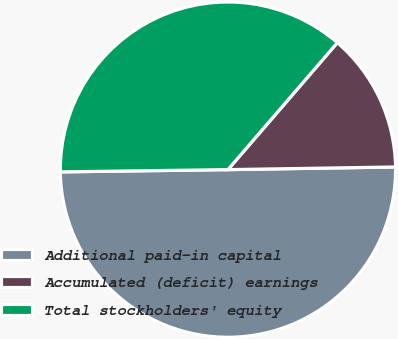Convert chart to OTSL. <chart><loc_0><loc_0><loc_500><loc_500><pie_chart><fcel>Additional paid-in capital<fcel>Accumulated (deficit) earnings<fcel>Total stockholders' equity<nl><fcel>50.04%<fcel>13.43%<fcel>36.54%<nl></chart> 